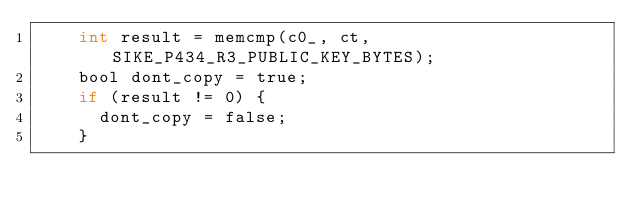Convert code to text. <code><loc_0><loc_0><loc_500><loc_500><_C_>    int result = memcmp(c0_, ct, SIKE_P434_R3_PUBLIC_KEY_BYTES);
    bool dont_copy = true;
    if (result != 0) {
      dont_copy = false;
    }
</code> 